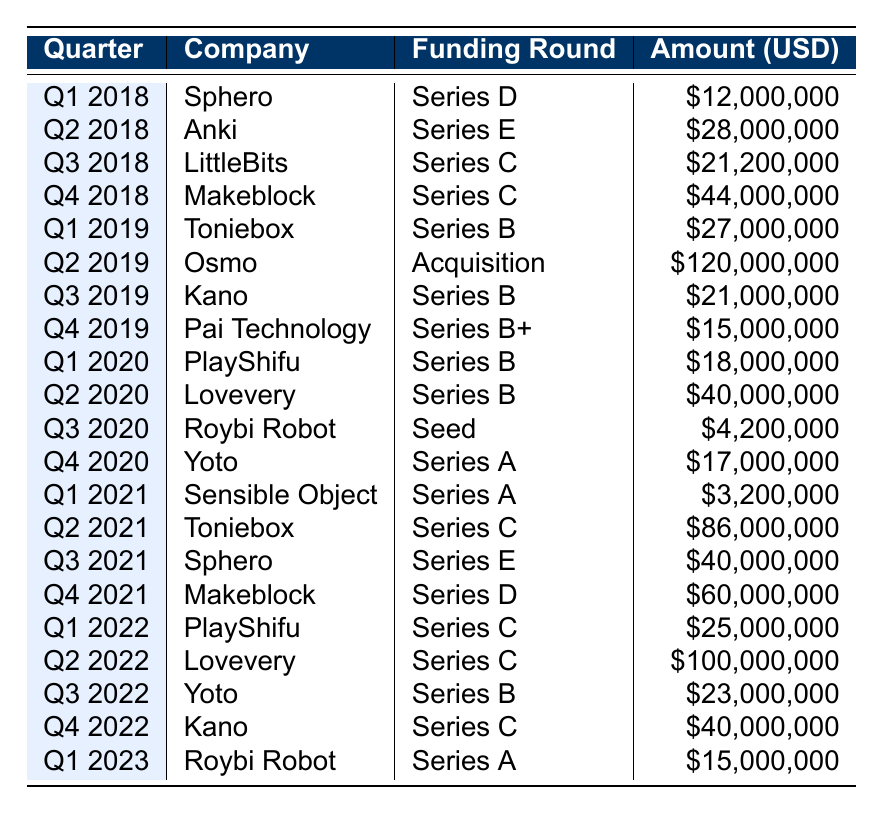What was the total funding amount for Sphero in 2021? In 2021, Sphero raised two funding amounts: $3,200,000 in Q1 and $40,000,000 in Q3. Adding these amounts together gives $3,200,000 + $40,000,000 = $43,200,000.
Answer: $43,200,000 Which company received the highest funding amount in a single round? Looking through the table, Osmo received the highest funding with $120,000,000 in Q2 2019, which is the maximum amount listed.
Answer: $120,000,000 Did Toniebox receive funding in more than one round? Yes, Toniebox received funding in two rounds: Series B in Q1 2019 and Series C in Q2 2021. Therefore, the statement is true.
Answer: Yes What is the average funding amount for Lovevery over all rounds? Lovevery raised funds in Q2 2020 for $40,000,000, Q2 2022 for $100,000,000, summing these gives $40,000,000 + $100,000,000 = $140,000,000. The average across the two rounds is $140,000,000 / 2 = $70,000,000.
Answer: $70,000,000 Which quarter saw the most funding across all companies? Summing the funding amounts per quarter shows: Q2 2021 has $86,000,000 (Toniebox) + $40,000,000 (Sphero) = $126,000,000. Q2 2022 has $100,000,000 (Lovevery), which is higher. So, Q2 2022 had the most funding.
Answer: Q2 2022 How many different companies received funding in Q4 2020? In Q4 2020, only Yoto received funding of $17,000,000, so there was just one company funded in that quarter.
Answer: 1 What is the total funding amount raised by Kano over the years? Kano raised funds in Q3 2019 ($21,000,000), Q4 2022 ($40,000,000), and Q2 2021 ($22,000,000). The total is $21,000,000 + $40,000,000 = $61,000,000.
Answer: $61,000,000 Was there any funding round in 2023? Yes, there was one funding round in Q1 2023 with Roybi Robot receiving $15,000,000. Thus, the statement is true.
Answer: Yes How does the funding amount for PlayShifu in 2020 compare to its 2021 funding? PlayShifu received $18,000,000 in Q1 2020 and $25,000,000 in Q1 2022. Comparing, $25,000,000 is greater than $18,000,000, so its funding increased.
Answer: Increased What is the median funding amount in the table? To find the median, we first list the funding amounts in ascending order, then identify the middle value. The sorted list of amounts includes 4,200,000, 3,200,000, ..., with the total number of rounds being 20. The median is the average of 25,000,000 (10th) and 27,000,000 (11th), totaling 51,000,000 / 2 = 25,500,000.
Answer: $25,500,000 